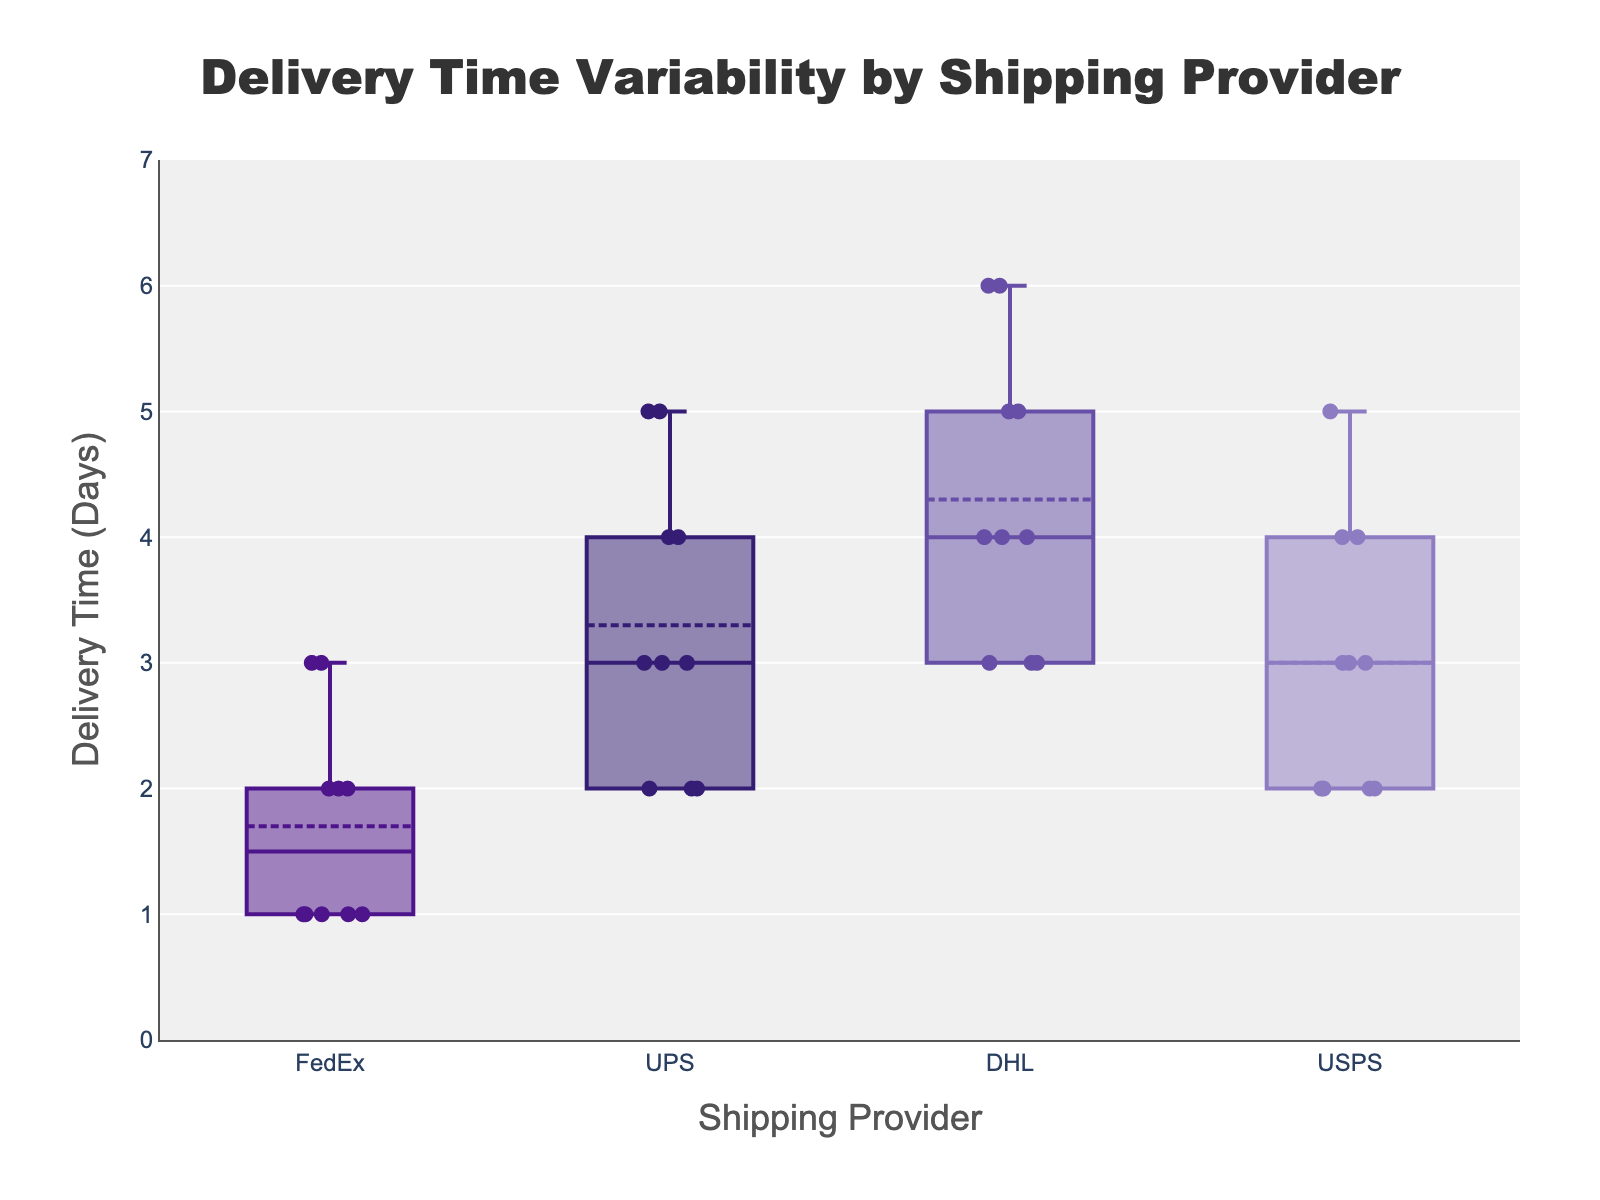What's the title of the figure? The title of the figure is prominently displayed at the top center, usually in larger and bolder font.
Answer: Delivery Time Variability by Shipping Provider What is the delivery time range displayed on the y-axis? The range on the y-axis is shown by the minimum and maximum values. It starts from 0 and goes up to 7 days.
Answer: 0 to 7 days Which shipping provider has the highest minimum delivery time? By looking at the bottom end of the box for each provider, we can determine the minimum delivery time. For DHL, the minimum delivery time is 3 days, which is higher than other providers.
Answer: DHL What's the median delivery time for UPS? The median is represented by the line inside the box. For UPS, this line is at 3 days.
Answer: 3 days Which shipping provider has the widest delivery time range? To determine the widest range, we need to look at the length of the box and the whiskers. DHL has data points ranging from 3 to 6 days, making it the widest range.
Answer: DHL Compare the median delivery times of FedEx and USPS. Which is shorter? By observing the median lines in the boxes for both providers, FedEx has a median of 2 days, and USPS also has a median of 2 days. Compare these two medians to answer.
Answer: Same How many outliers does UPS have? Outliers are represented by individual points outside the whiskers. In the case of UPS, there are no points outside the whiskers, indicating no outliers.
Answer: 0 Which shipping provider has the most consistent (lowest variability) delivery time? Consistency can be inferred from the smallest interquartile range (IQR), which is the box length. FedEx has the smallest box, indicating the most consistent delivery time.
Answer: FedEx 